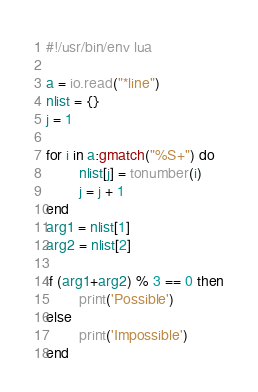<code> <loc_0><loc_0><loc_500><loc_500><_Lua_>#!/usr/bin/env lua

a = io.read("*line")
nlist = {}
j = 1

for i in a:gmatch("%S+") do
        nlist[j] = tonumber(i)
        j = j + 1
end
arg1 = nlist[1]
arg2 = nlist[2]

if (arg1+arg2) % 3 == 0 then
        print('Possible')
else
        print('Impossible')
end
</code> 